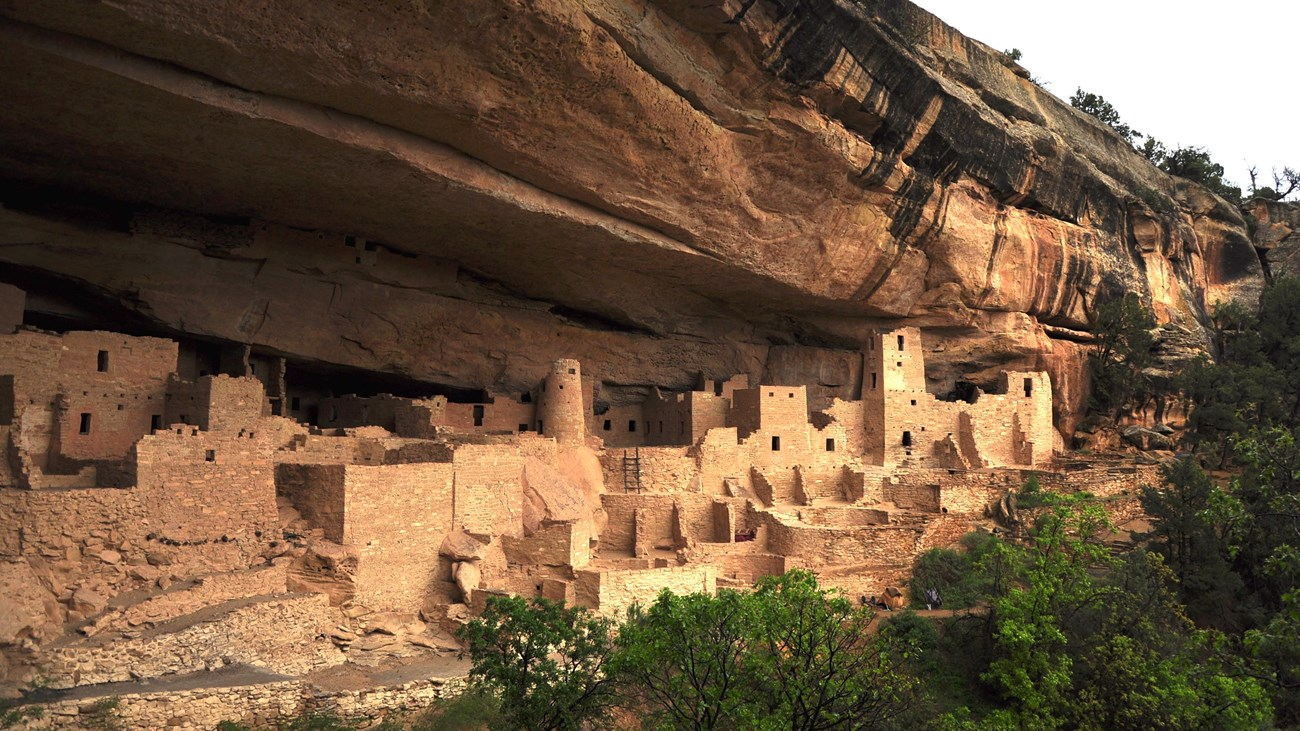What might have been some of the daily activities for the inhabitants of these cliff dwellings? The inhabitants of these cliff dwellings, the ancient Puebloan people, engaged in a variety of daily activities that were integral to their survival and community life. They would have spent their days farming the arid land above the cliffs, cultivating crops such as corn, beans, and squash. Within the dwellings, women typically prepared meals, ground corn into flour, and crafted pottery. Men might have spent time making tools and hunting for game in the surrounding landscape. Children played, learned skills from their elders, and helped with chores. The intricate architecture suggests a well-organized society that also engaged in trade, religious ceremonies, and communal gatherings, emphasizing their strong social and cultural bonds. 